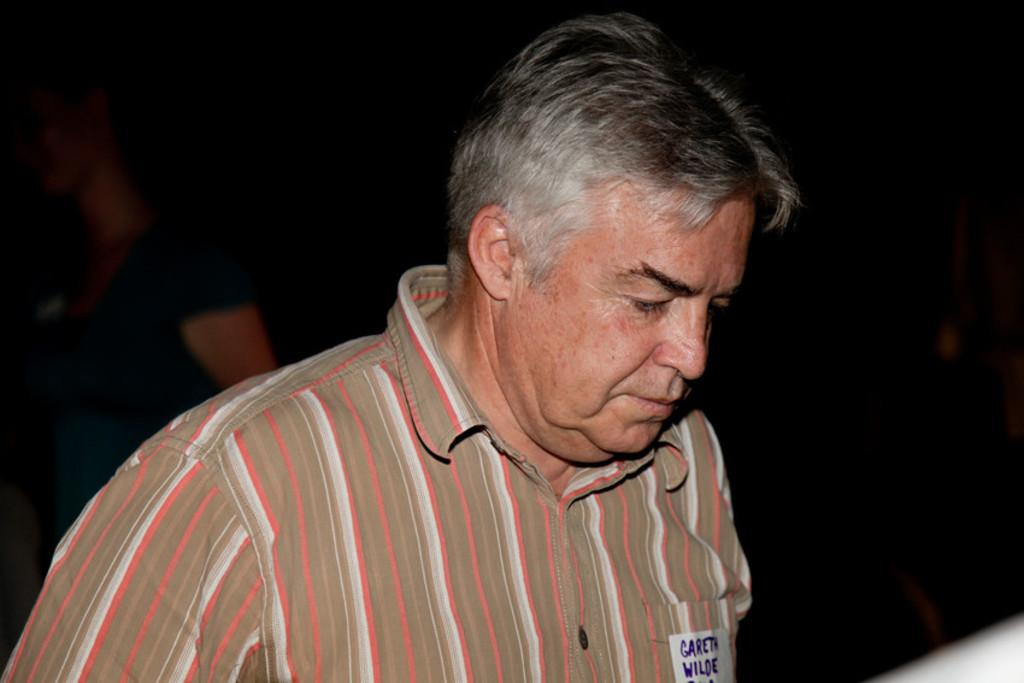What is the main subject of the image? The main subject of the image is a man. What type of instrument is the man playing in the image? There is no instrument present in the image, as it only features a man. 